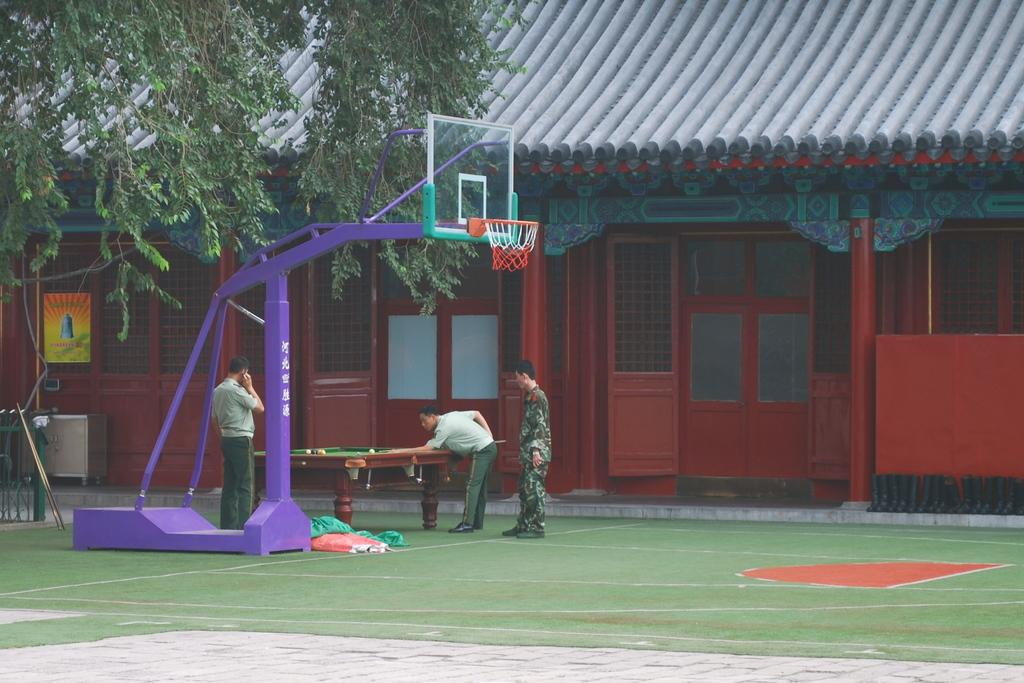How many people are on the left side of the image? There are three people on the left side of the image. What are the people doing in the image? One of the people is playing a snooker game. What other objects or features can be seen in the image? There is a basketball net, a tree, a house, and a door associated with the house in the image. What direction is the wind blowing in the image? There is no indication of wind in the image, so it cannot be determined from the image. 